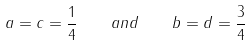Convert formula to latex. <formula><loc_0><loc_0><loc_500><loc_500>a = c = { \frac { 1 } { 4 } } \quad a n d \quad b = d = { \frac { 3 } { 4 } }</formula> 